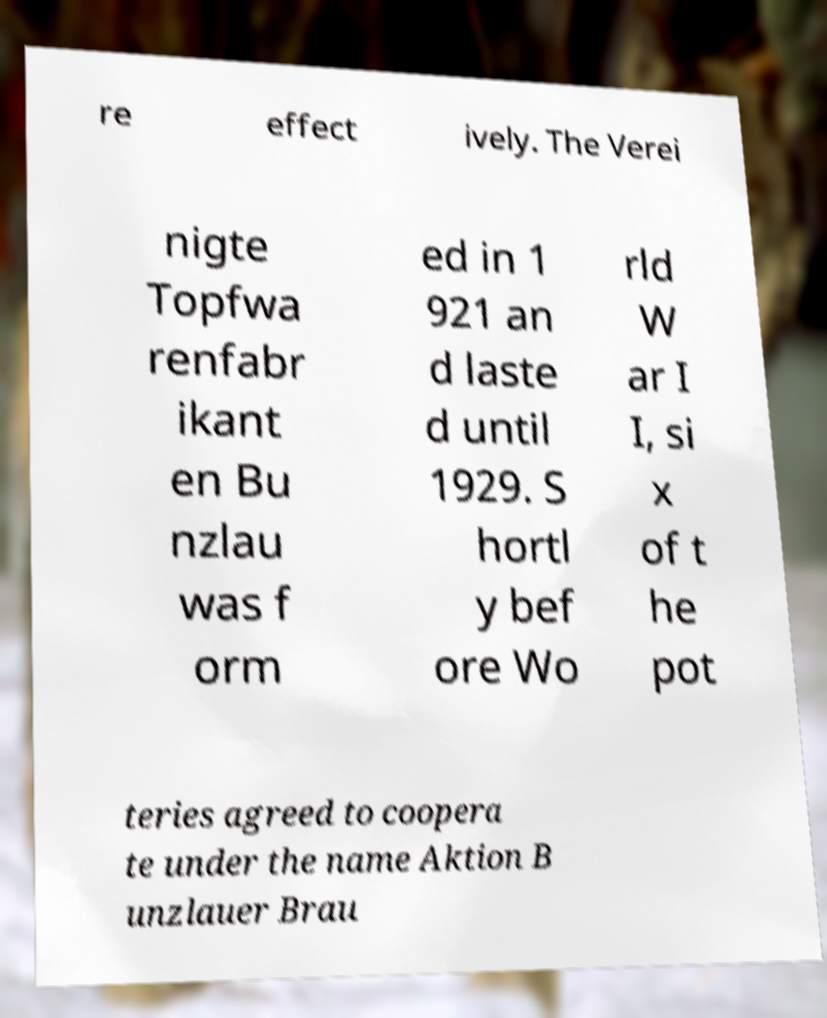Can you read and provide the text displayed in the image?This photo seems to have some interesting text. Can you extract and type it out for me? re effect ively. The Verei nigte Topfwa renfabr ikant en Bu nzlau was f orm ed in 1 921 an d laste d until 1929. S hortl y bef ore Wo rld W ar I I, si x of t he pot teries agreed to coopera te under the name Aktion B unzlauer Brau 